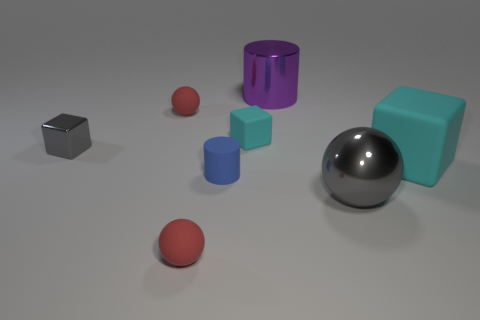What size is the thing that is both right of the tiny cyan matte cube and in front of the tiny blue matte thing? There are several objects in the scene, but none precisely match the criteria of being both to the right of a tiny cyan cube and in front of a tiny blue object. The large silver sphere appears closest to the cyan cube but is not directly to its right. Please verify if this is the object in question. 